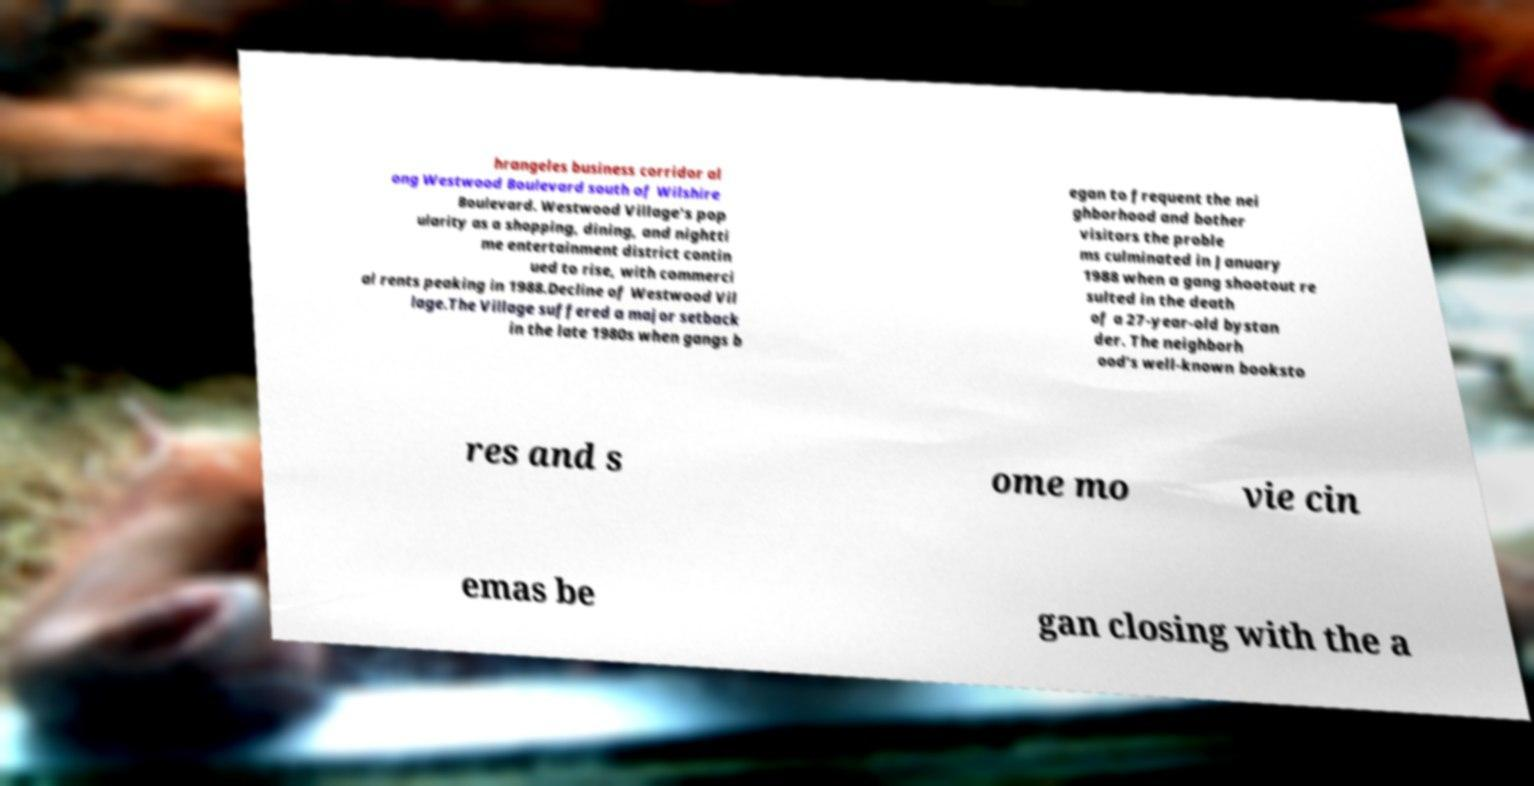Can you read and provide the text displayed in the image?This photo seems to have some interesting text. Can you extract and type it out for me? hrangeles business corridor al ong Westwood Boulevard south of Wilshire Boulevard. Westwood Village's pop ularity as a shopping, dining, and nightti me entertainment district contin ued to rise, with commerci al rents peaking in 1988.Decline of Westwood Vil lage.The Village suffered a major setback in the late 1980s when gangs b egan to frequent the nei ghborhood and bother visitors the proble ms culminated in January 1988 when a gang shootout re sulted in the death of a 27-year-old bystan der. The neighborh ood's well-known booksto res and s ome mo vie cin emas be gan closing with the a 